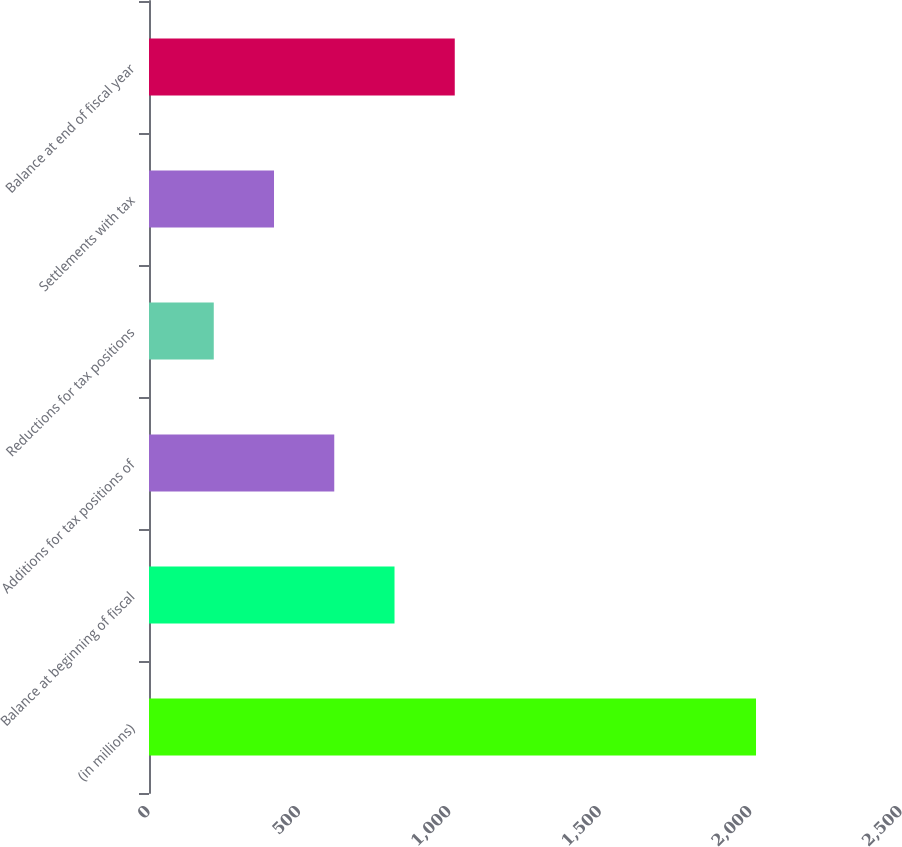Convert chart to OTSL. <chart><loc_0><loc_0><loc_500><loc_500><bar_chart><fcel>(in millions)<fcel>Balance at beginning of fiscal<fcel>Additions for tax positions of<fcel>Reductions for tax positions<fcel>Settlements with tax<fcel>Balance at end of fiscal year<nl><fcel>2018<fcel>816.2<fcel>615.9<fcel>215.3<fcel>415.6<fcel>1016.5<nl></chart> 